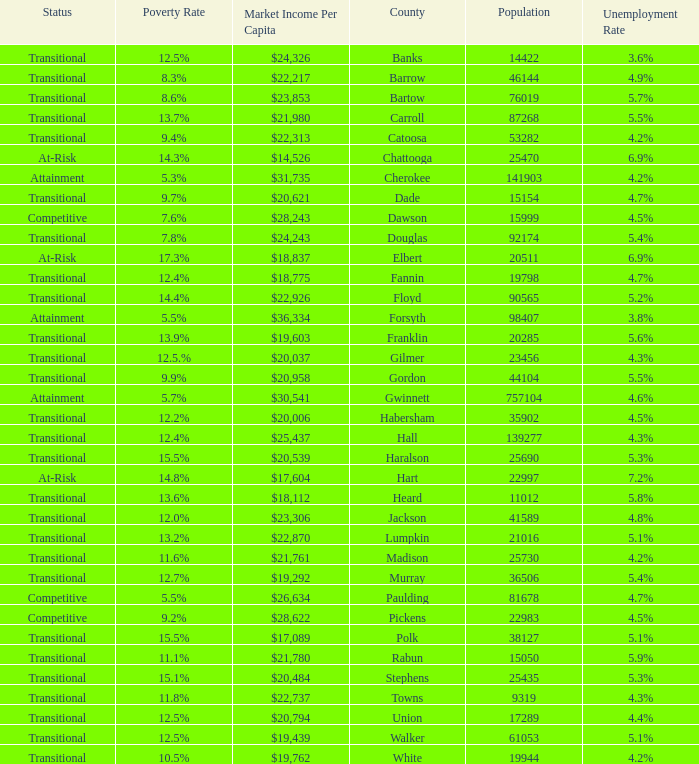What is the status of the county with per capita market income of $24,326? Transitional. 